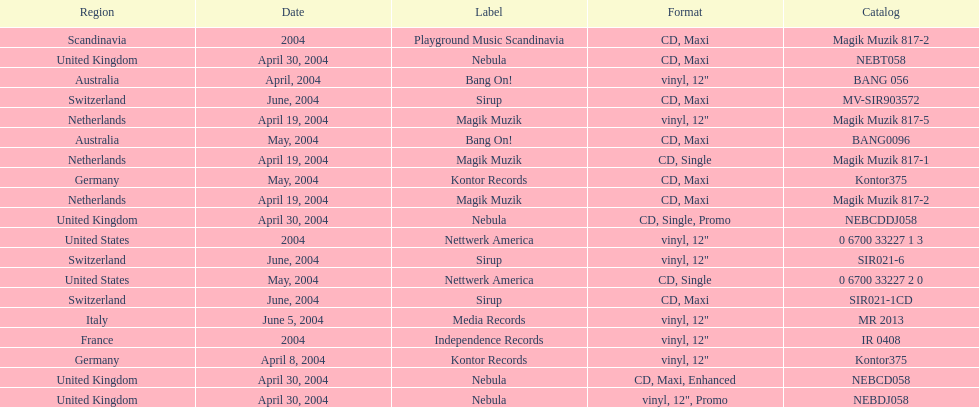What region is above australia? Germany. 